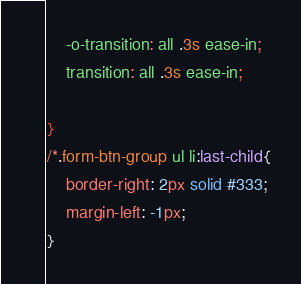<code> <loc_0><loc_0><loc_500><loc_500><_CSS_>    -o-transition: all .3s ease-in;
    transition: all .3s ease-in;

}
/*.form-btn-group ul li:last-child{
    border-right: 2px solid #333;
    margin-left: -1px;
}</code> 